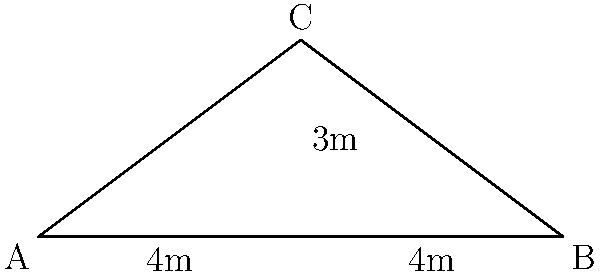You're inspecting a potential rental property and notice the roof needs better insulation. To determine the amount of insulation material needed, you must calculate the angle of the sloped roof. The roof forms a triangle with a base width of 8 meters and a height of 3 meters at the center. What is the angle of the roof slope in degrees? Let's approach this step-by-step:

1) The roof forms a triangle. We're given the base (8 meters) and the height (3 meters).

2) The triangle is isosceles, as the peak is in the center. This means we can split it into two right-angled triangles.

3) For one of these right-angled triangles:
   - The base is half of the total width: 8/2 = 4 meters
   - The height remains 3 meters

4) We can use the tangent function to find the angle. In a right-angled triangle:

   $\tan(\theta) = \frac{\text{opposite}}{\text{adjacent}} = \frac{\text{height}}{\text{half base}}$

5) Plugging in our values:

   $\tan(\theta) = \frac{3}{4}$

6) To find the angle, we need to use the inverse tangent (arctan or $\tan^{-1}$):

   $\theta = \tan^{-1}(\frac{3}{4})$

7) Using a calculator or programming function:

   $\theta \approx 36.87°$

Therefore, the angle of the roof slope is approximately 36.87 degrees.
Answer: 36.87° 